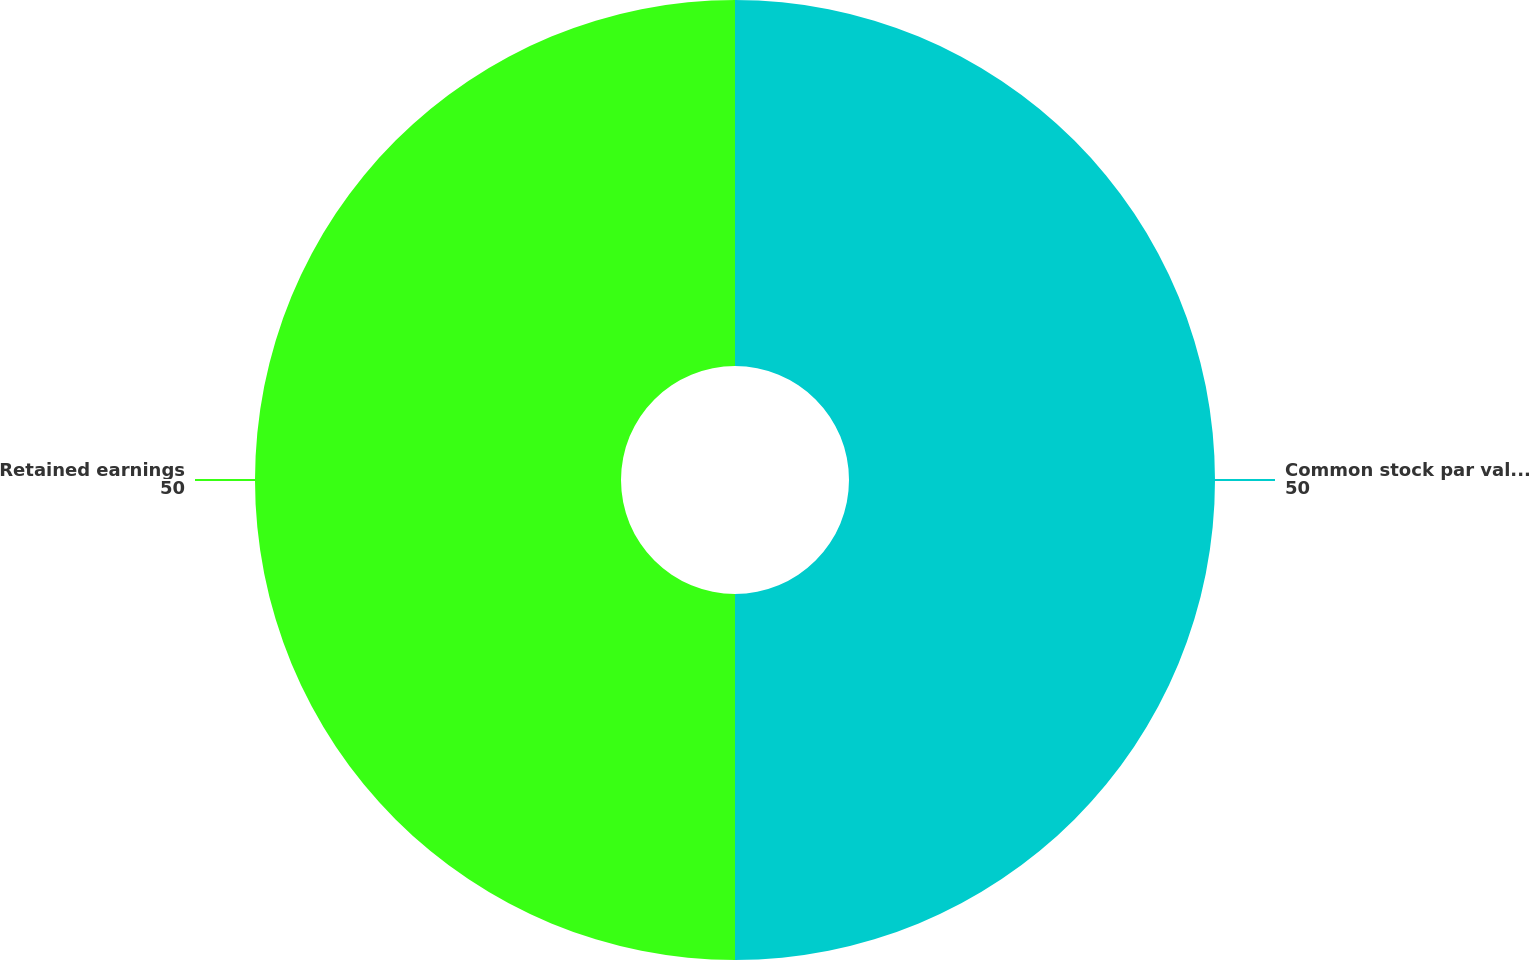Convert chart to OTSL. <chart><loc_0><loc_0><loc_500><loc_500><pie_chart><fcel>Common stock par value 1 per<fcel>Retained earnings<nl><fcel>50.0%<fcel>50.0%<nl></chart> 